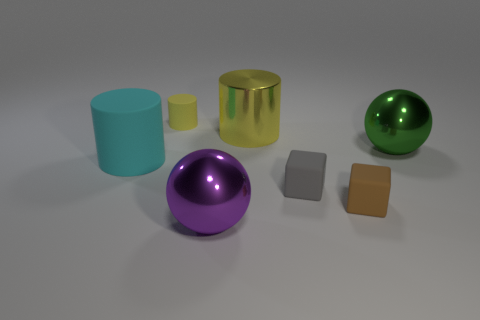Is there another object that has the same size as the yellow matte object?
Provide a short and direct response. Yes. Is the shape of the small yellow rubber object the same as the metal object that is to the left of the large shiny cylinder?
Make the answer very short. No. What number of cylinders are either small yellow objects or tiny gray things?
Your response must be concise. 1. The small matte cylinder is what color?
Give a very brief answer. Yellow. Are there more yellow things than big rubber objects?
Make the answer very short. Yes. How many things are either large objects that are in front of the small gray rubber block or big yellow metallic things?
Your response must be concise. 2. Is the big green ball made of the same material as the cyan cylinder?
Make the answer very short. No. There is another thing that is the same shape as the large purple metal object; what is its size?
Make the answer very short. Large. Does the metallic object behind the large green shiny sphere have the same shape as the cyan rubber object left of the brown cube?
Make the answer very short. Yes. Do the brown matte thing and the yellow cylinder to the left of the purple metallic object have the same size?
Your answer should be very brief. Yes. 